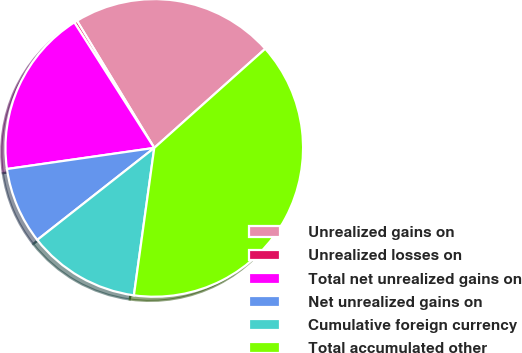Convert chart to OTSL. <chart><loc_0><loc_0><loc_500><loc_500><pie_chart><fcel>Unrealized gains on<fcel>Unrealized losses on<fcel>Total net unrealized gains on<fcel>Net unrealized gains on<fcel>Cumulative foreign currency<fcel>Total accumulated other<nl><fcel>22.09%<fcel>0.33%<fcel>18.24%<fcel>8.34%<fcel>12.21%<fcel>38.79%<nl></chart> 